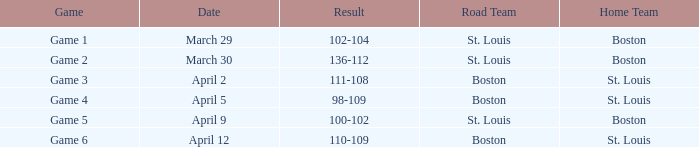What is the Result of the Game on April 9? 100-102. 